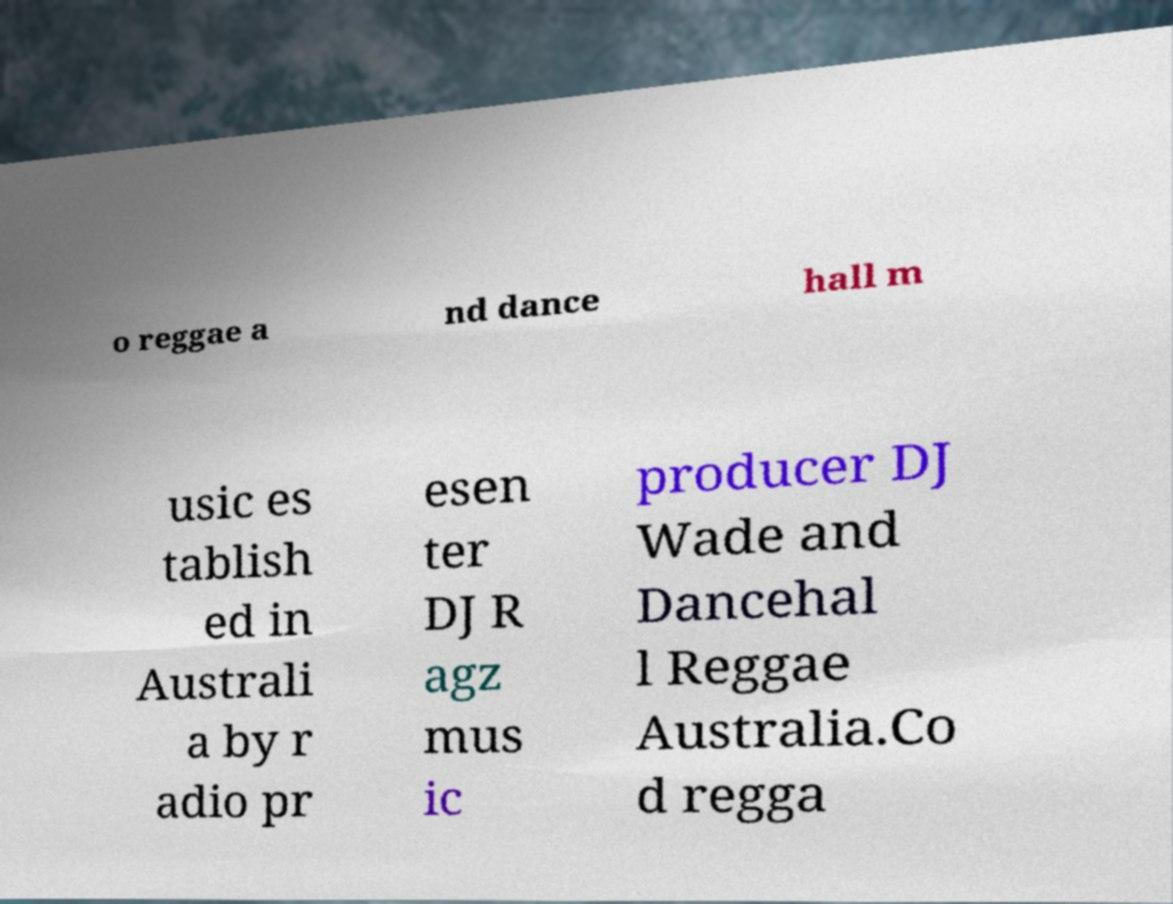Can you read and provide the text displayed in the image?This photo seems to have some interesting text. Can you extract and type it out for me? o reggae a nd dance hall m usic es tablish ed in Australi a by r adio pr esen ter DJ R agz mus ic producer DJ Wade and Dancehal l Reggae Australia.Co d regga 